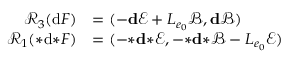<formula> <loc_0><loc_0><loc_500><loc_500>\begin{array} { r l } { \mathcal { R } _ { 3 } ( d F ) } & { = ( - d \ m a t h s c r { E } + L _ { e _ { 0 } } \ m a t h s c r { B } , d \ m a t h s c r { B } ) } \\ { \mathcal { R } _ { 1 } ( { * } d { * } F ) } & { = ( - { * } d { * } \ m a t h s c r { E } , - { * } d { * } \ m a t h s c r { B } - L _ { e _ { 0 } } \ m a t h s c r { E } ) } \end{array}</formula> 